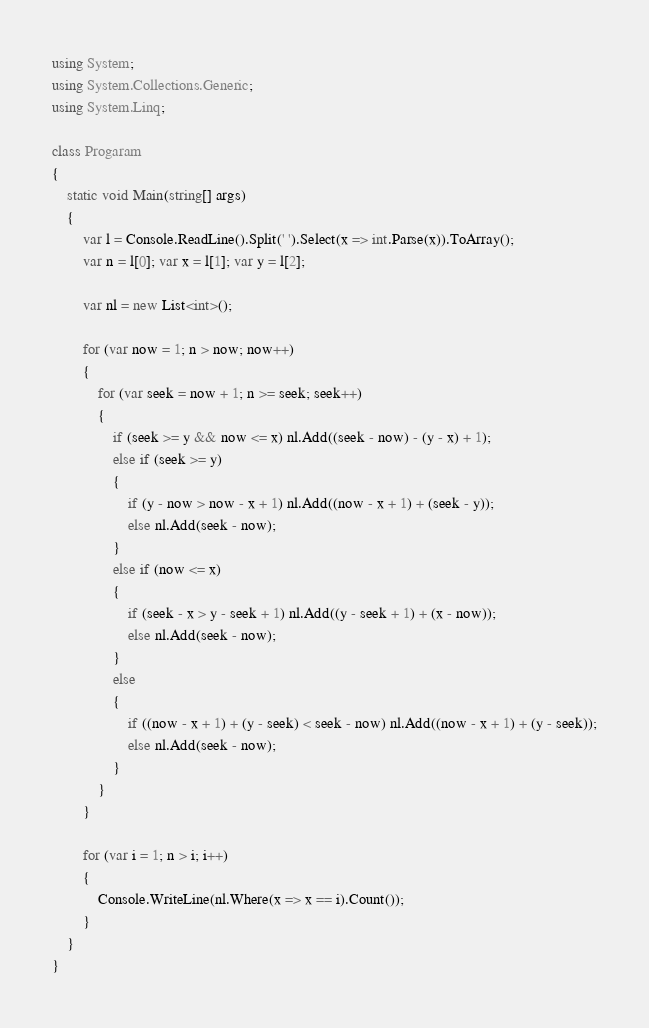Convert code to text. <code><loc_0><loc_0><loc_500><loc_500><_C#_>using System;
using System.Collections.Generic;
using System.Linq;

class Progaram
{
    static void Main(string[] args)
    {
        var l = Console.ReadLine().Split(' ').Select(x => int.Parse(x)).ToArray();
        var n = l[0]; var x = l[1]; var y = l[2];

        var nl = new List<int>();

        for (var now = 1; n > now; now++)
        {
            for (var seek = now + 1; n >= seek; seek++)
            {
                if (seek >= y && now <= x) nl.Add((seek - now) - (y - x) + 1);
                else if (seek >= y)
                {
                    if (y - now > now - x + 1) nl.Add((now - x + 1) + (seek - y));
                    else nl.Add(seek - now);
                }
                else if (now <= x)
                {
                    if (seek - x > y - seek + 1) nl.Add((y - seek + 1) + (x - now));
                    else nl.Add(seek - now);
                }
                else
                {
                    if ((now - x + 1) + (y - seek) < seek - now) nl.Add((now - x + 1) + (y - seek));
                    else nl.Add(seek - now);
                }
            }
        }

        for (var i = 1; n > i; i++)
        {
            Console.WriteLine(nl.Where(x => x == i).Count());
        }
    }
}</code> 